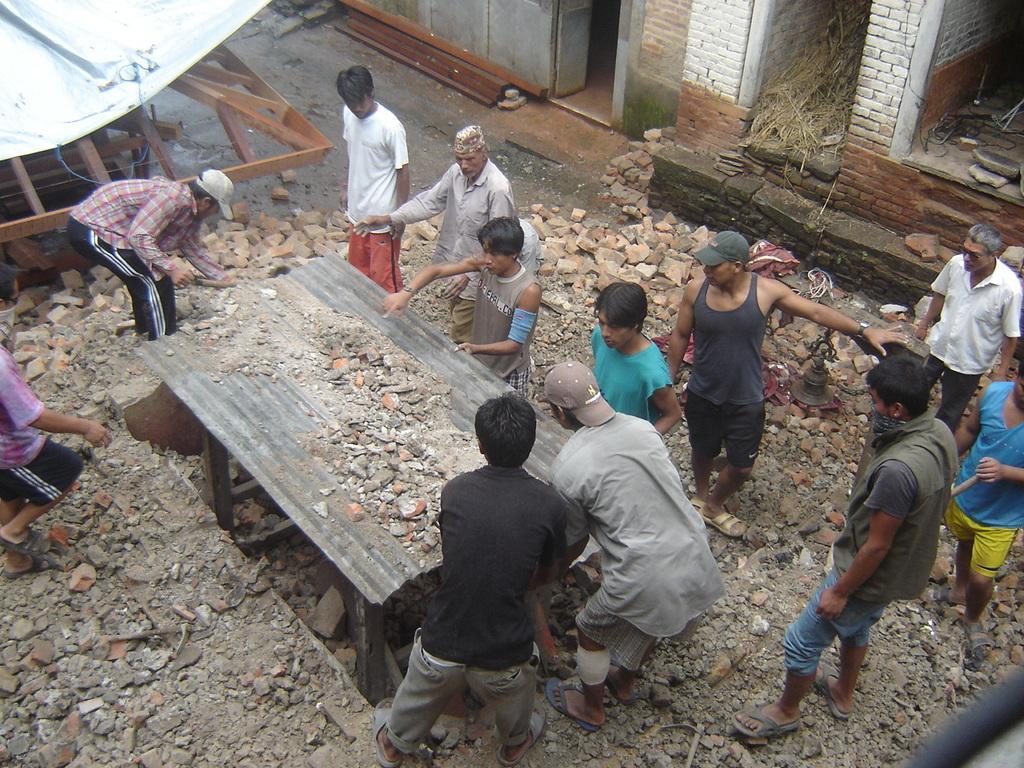How would you summarize this image in a sentence or two? In this image, in the middle, we can see a group of people are standing in front of the table. On the table, we can see some sand with stones. On the right side, we can see two men are standing. In the right corner, we can see an object. On the left side, we can see a person walking. On the left side, we can also see another person. In the background, we can see some wood, tent. In the background, we can also see some grass and some metal instrument. At the bottom, we can see a road and a sand with some stones. 